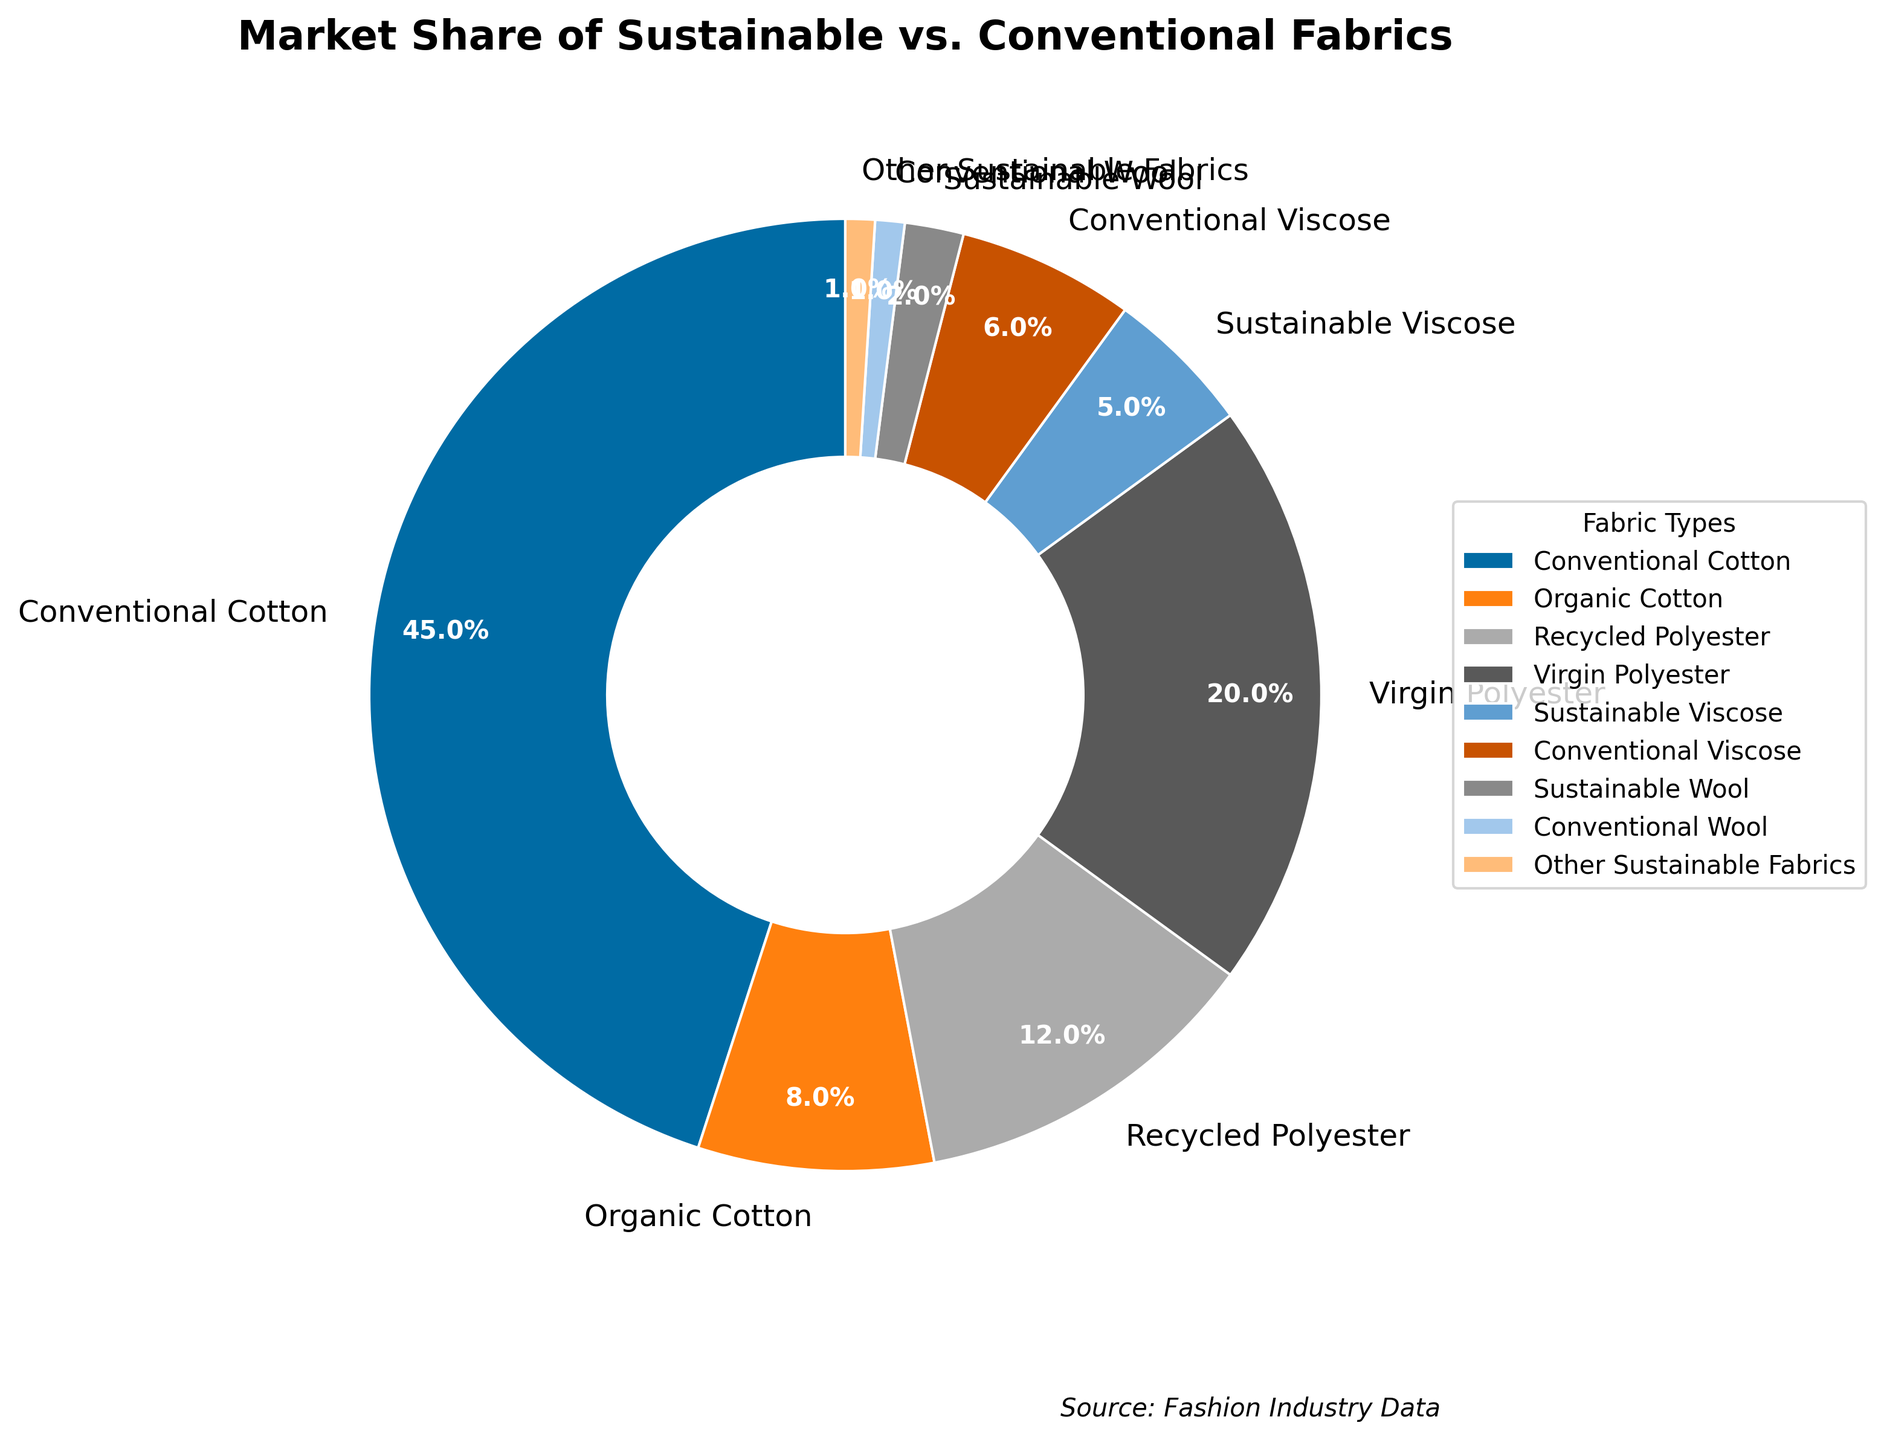What is the market share of Conventional Cotton? From the pie chart's labels, we can see that "Conventional Cotton" takes up 45% of the market share.
Answer: 45% What is the combined market share of all sustainable fabrics? Summing up the market shares of sustainable fabrics: Organic Cotton (8%), Recycled Polyester (12%), Sustainable Viscose (5%), Sustainable Wool (2%), and Other Sustainable Fabrics (1%). The total is 8 + 12 + 5 + 2 + 1 = 28%.
Answer: 28% Which fabric type has the least market share and what is it? By observing the pie chart, the smallest wedge corresponds to "Conventional Wool", which has a market share of 1%.
Answer: Conventional Wool How does the market share of Recycled Polyester compare to that of Virgin Polyester? From the pie chart, Recycled Polyester has a market share of 12%, whereas Virgin Polyester has a market share of 20%. So, Recycled Polyester's share is less.
Answer: Less What is the difference between the market shares of Conventional Cotton and Organic Cotton? Conventional Cotton has a market share of 45%, whereas Organic Cotton has 8%. The difference is 45 - 8 = 37%.
Answer: 37% What is the market share of Virgin Polyester relative to Conventional Cotton? Virgin Polyester has a market share of 20% and Conventional Cotton has 45%. The relative comparison can be expressed as 20/45 ≈ 0.44, or 44%.
Answer: 44% What percentage of the market share does the entire Viscose category (both sustainable and conventional) constitute? Adding the market share of Sustainable Viscose (5%) and Conventional Viscose (6%) gives us 5 + 6 = 11%.
Answer: 11% How is Sustainable Wool represented visually in the pie chart? Sustainable Wool is represented by a small wedge labeled with 2%, located among the smaller sections of the pie chart.
Answer: 2% Compare the market share of Virgin Polyester to the combined share of all types of Cotton. The market share of Virgin Polyester is 20%. The combined market share of all types of Cotton (Conventional Cotton and Organic Cotton) is 45 + 8 = 53%. Virgin Polyester's share is less in comparison.
Answer: Less What is the visual significance of the largest segment in the pie chart? The largest segment in the pie chart corresponds to Conventional Cotton, highlighting its dominance with a 45% market share.
Answer: Conventional Cotton 